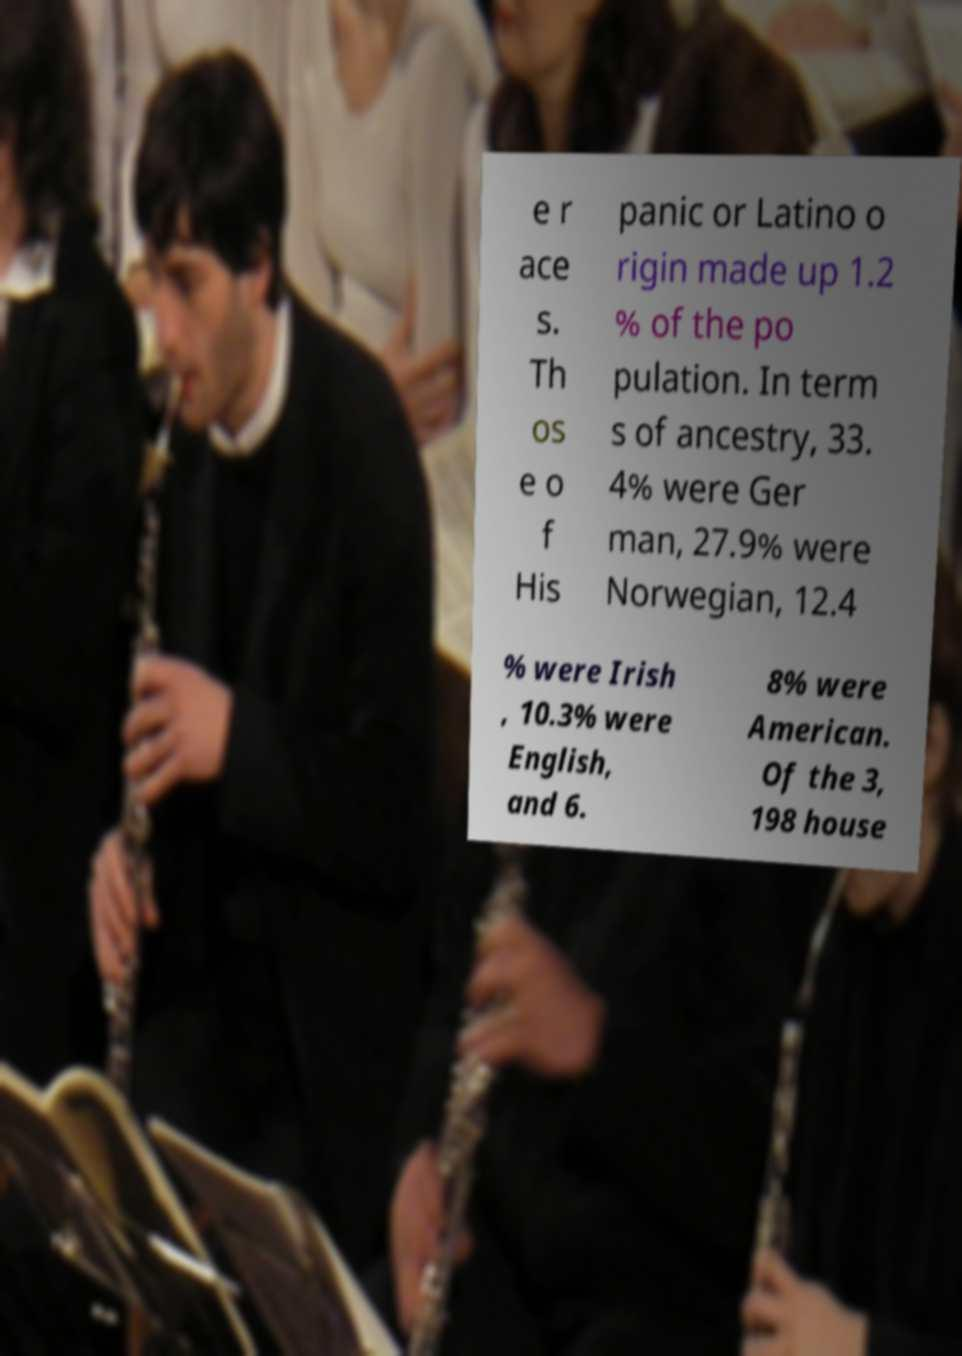Could you extract and type out the text from this image? e r ace s. Th os e o f His panic or Latino o rigin made up 1.2 % of the po pulation. In term s of ancestry, 33. 4% were Ger man, 27.9% were Norwegian, 12.4 % were Irish , 10.3% were English, and 6. 8% were American. Of the 3, 198 house 